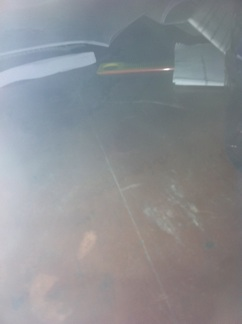What objects can you identify on the table? I can identify a book and a pen on the table. Can you describe the condition of the table? The table appears to have some smudges or stains on its surface, suggesting it might need some cleaning. 